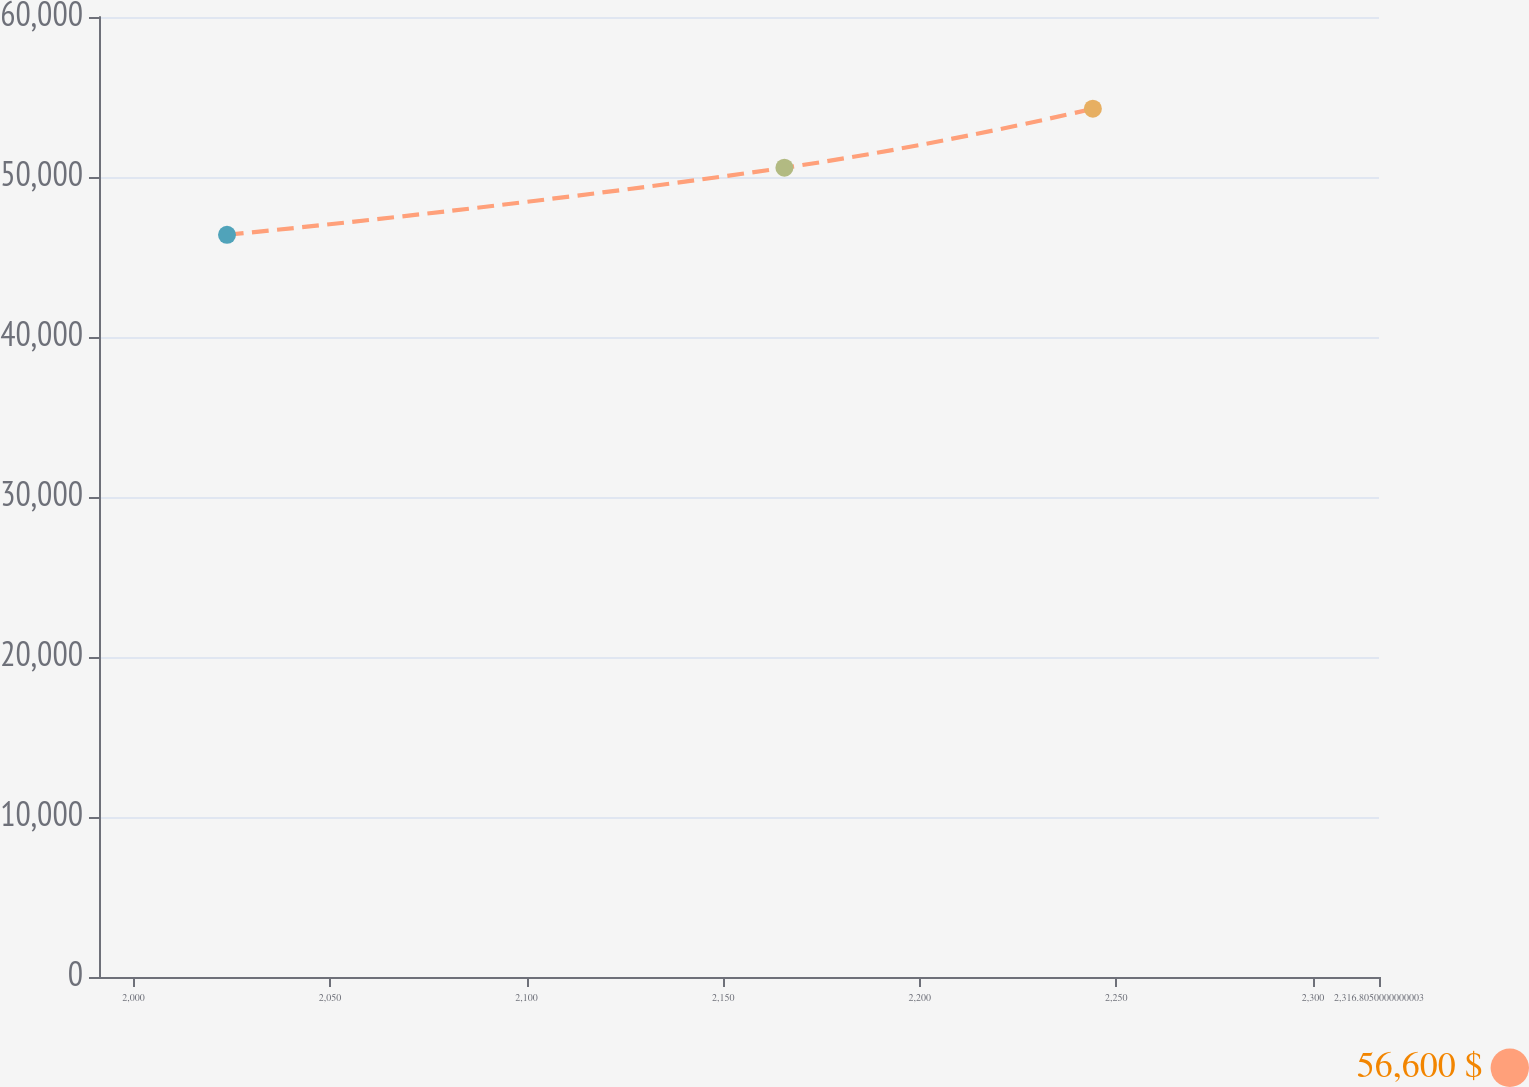Convert chart to OTSL. <chart><loc_0><loc_0><loc_500><loc_500><line_chart><ecel><fcel>56,600 $<nl><fcel>2023.81<fcel>46389.9<nl><fcel>2165.58<fcel>50579.2<nl><fcel>2244.03<fcel>54266.5<nl><fcel>2349.36<fcel>59496.7<nl></chart> 